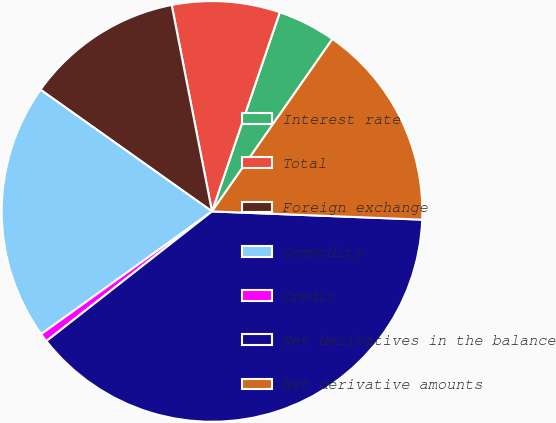Convert chart to OTSL. <chart><loc_0><loc_0><loc_500><loc_500><pie_chart><fcel>Interest rate<fcel>Total<fcel>Foreign exchange<fcel>Commodity<fcel>Credit<fcel>Net derivatives in the balance<fcel>Net derivative amounts<nl><fcel>4.48%<fcel>8.29%<fcel>12.11%<fcel>19.73%<fcel>0.66%<fcel>38.8%<fcel>15.92%<nl></chart> 